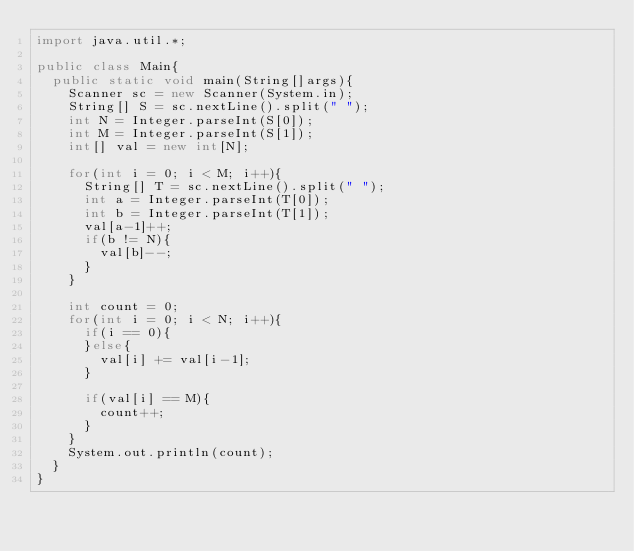<code> <loc_0><loc_0><loc_500><loc_500><_Java_>import java.util.*;

public class Main{
  public static void main(String[]args){
    Scanner sc = new Scanner(System.in);
    String[] S = sc.nextLine().split(" ");
    int N = Integer.parseInt(S[0]);
    int M = Integer.parseInt(S[1]);
    int[] val = new int[N];
    
    for(int i = 0; i < M; i++){
      String[] T = sc.nextLine().split(" ");
      int a = Integer.parseInt(T[0]);
      int b = Integer.parseInt(T[1]);
      val[a-1]++;
      if(b != N){
        val[b]--;
      }
    }
    
    int count = 0;
    for(int i = 0; i < N; i++){
      if(i == 0){
      }else{
        val[i] += val[i-1];
      }
      
      if(val[i] == M){
        count++;
      }
    }
    System.out.println(count);
  }
}</code> 